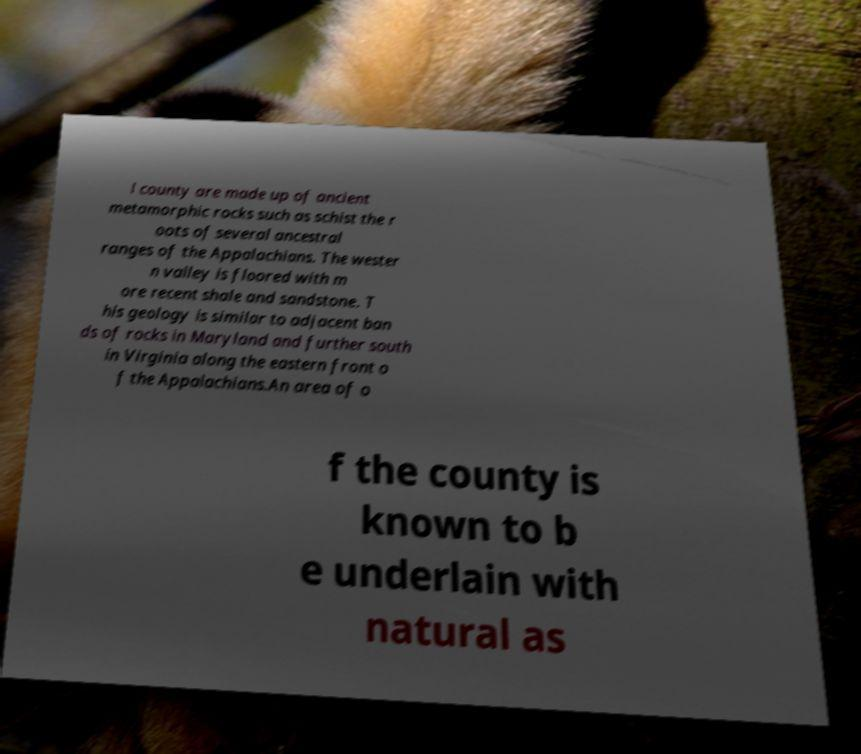Could you assist in decoding the text presented in this image and type it out clearly? l county are made up of ancient metamorphic rocks such as schist the r oots of several ancestral ranges of the Appalachians. The wester n valley is floored with m ore recent shale and sandstone. T his geology is similar to adjacent ban ds of rocks in Maryland and further south in Virginia along the eastern front o f the Appalachians.An area of o f the county is known to b e underlain with natural as 